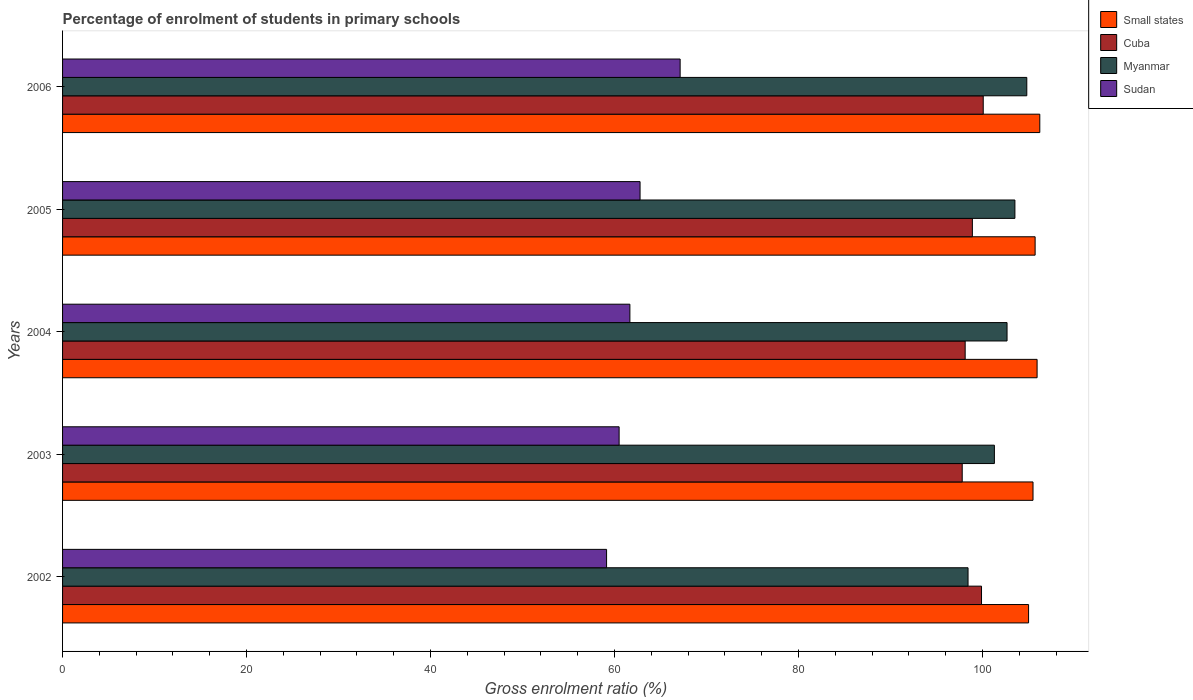How many different coloured bars are there?
Offer a terse response. 4. Are the number of bars per tick equal to the number of legend labels?
Your answer should be very brief. Yes. How many bars are there on the 5th tick from the top?
Give a very brief answer. 4. How many bars are there on the 5th tick from the bottom?
Your answer should be compact. 4. In how many cases, is the number of bars for a given year not equal to the number of legend labels?
Ensure brevity in your answer.  0. What is the percentage of students enrolled in primary schools in Sudan in 2004?
Your response must be concise. 61.67. Across all years, what is the maximum percentage of students enrolled in primary schools in Small states?
Provide a short and direct response. 106.23. Across all years, what is the minimum percentage of students enrolled in primary schools in Sudan?
Offer a terse response. 59.14. In which year was the percentage of students enrolled in primary schools in Cuba maximum?
Keep it short and to the point. 2006. In which year was the percentage of students enrolled in primary schools in Myanmar minimum?
Provide a short and direct response. 2002. What is the total percentage of students enrolled in primary schools in Small states in the graph?
Ensure brevity in your answer.  528.38. What is the difference between the percentage of students enrolled in primary schools in Myanmar in 2002 and that in 2006?
Your response must be concise. -6.39. What is the difference between the percentage of students enrolled in primary schools in Small states in 2005 and the percentage of students enrolled in primary schools in Cuba in 2002?
Ensure brevity in your answer.  5.83. What is the average percentage of students enrolled in primary schools in Sudan per year?
Ensure brevity in your answer.  62.24. In the year 2004, what is the difference between the percentage of students enrolled in primary schools in Myanmar and percentage of students enrolled in primary schools in Sudan?
Keep it short and to the point. 41. What is the ratio of the percentage of students enrolled in primary schools in Cuba in 2004 to that in 2005?
Your response must be concise. 0.99. What is the difference between the highest and the second highest percentage of students enrolled in primary schools in Small states?
Your answer should be very brief. 0.29. What is the difference between the highest and the lowest percentage of students enrolled in primary schools in Small states?
Offer a terse response. 1.22. Is the sum of the percentage of students enrolled in primary schools in Myanmar in 2002 and 2003 greater than the maximum percentage of students enrolled in primary schools in Small states across all years?
Provide a short and direct response. Yes. Is it the case that in every year, the sum of the percentage of students enrolled in primary schools in Sudan and percentage of students enrolled in primary schools in Cuba is greater than the sum of percentage of students enrolled in primary schools in Myanmar and percentage of students enrolled in primary schools in Small states?
Offer a very short reply. Yes. What does the 4th bar from the top in 2006 represents?
Give a very brief answer. Small states. What does the 4th bar from the bottom in 2004 represents?
Provide a short and direct response. Sudan. Is it the case that in every year, the sum of the percentage of students enrolled in primary schools in Sudan and percentage of students enrolled in primary schools in Cuba is greater than the percentage of students enrolled in primary schools in Small states?
Give a very brief answer. Yes. How many bars are there?
Your answer should be very brief. 20. Are all the bars in the graph horizontal?
Offer a very short reply. Yes. What is the difference between two consecutive major ticks on the X-axis?
Provide a succinct answer. 20. Does the graph contain grids?
Keep it short and to the point. No. What is the title of the graph?
Keep it short and to the point. Percentage of enrolment of students in primary schools. Does "Curacao" appear as one of the legend labels in the graph?
Your answer should be very brief. No. What is the label or title of the X-axis?
Your answer should be compact. Gross enrolment ratio (%). What is the label or title of the Y-axis?
Offer a very short reply. Years. What is the Gross enrolment ratio (%) in Small states in 2002?
Give a very brief answer. 105.01. What is the Gross enrolment ratio (%) of Cuba in 2002?
Ensure brevity in your answer.  99.89. What is the Gross enrolment ratio (%) in Myanmar in 2002?
Give a very brief answer. 98.43. What is the Gross enrolment ratio (%) in Sudan in 2002?
Provide a succinct answer. 59.14. What is the Gross enrolment ratio (%) of Small states in 2003?
Make the answer very short. 105.49. What is the Gross enrolment ratio (%) of Cuba in 2003?
Ensure brevity in your answer.  97.79. What is the Gross enrolment ratio (%) of Myanmar in 2003?
Give a very brief answer. 101.29. What is the Gross enrolment ratio (%) of Sudan in 2003?
Your answer should be very brief. 60.5. What is the Gross enrolment ratio (%) in Small states in 2004?
Make the answer very short. 105.93. What is the Gross enrolment ratio (%) of Cuba in 2004?
Your response must be concise. 98.12. What is the Gross enrolment ratio (%) in Myanmar in 2004?
Make the answer very short. 102.67. What is the Gross enrolment ratio (%) of Sudan in 2004?
Make the answer very short. 61.67. What is the Gross enrolment ratio (%) of Small states in 2005?
Your answer should be very brief. 105.72. What is the Gross enrolment ratio (%) of Cuba in 2005?
Your response must be concise. 98.9. What is the Gross enrolment ratio (%) of Myanmar in 2005?
Your answer should be very brief. 103.52. What is the Gross enrolment ratio (%) of Sudan in 2005?
Provide a short and direct response. 62.78. What is the Gross enrolment ratio (%) of Small states in 2006?
Offer a very short reply. 106.23. What is the Gross enrolment ratio (%) in Cuba in 2006?
Give a very brief answer. 100.08. What is the Gross enrolment ratio (%) of Myanmar in 2006?
Your answer should be very brief. 104.82. What is the Gross enrolment ratio (%) of Sudan in 2006?
Keep it short and to the point. 67.13. Across all years, what is the maximum Gross enrolment ratio (%) of Small states?
Your answer should be compact. 106.23. Across all years, what is the maximum Gross enrolment ratio (%) in Cuba?
Keep it short and to the point. 100.08. Across all years, what is the maximum Gross enrolment ratio (%) in Myanmar?
Your response must be concise. 104.82. Across all years, what is the maximum Gross enrolment ratio (%) in Sudan?
Keep it short and to the point. 67.13. Across all years, what is the minimum Gross enrolment ratio (%) in Small states?
Make the answer very short. 105.01. Across all years, what is the minimum Gross enrolment ratio (%) in Cuba?
Provide a short and direct response. 97.79. Across all years, what is the minimum Gross enrolment ratio (%) in Myanmar?
Ensure brevity in your answer.  98.43. Across all years, what is the minimum Gross enrolment ratio (%) of Sudan?
Make the answer very short. 59.14. What is the total Gross enrolment ratio (%) of Small states in the graph?
Offer a terse response. 528.38. What is the total Gross enrolment ratio (%) in Cuba in the graph?
Offer a terse response. 494.78. What is the total Gross enrolment ratio (%) in Myanmar in the graph?
Your answer should be compact. 510.72. What is the total Gross enrolment ratio (%) of Sudan in the graph?
Offer a terse response. 311.21. What is the difference between the Gross enrolment ratio (%) in Small states in 2002 and that in 2003?
Ensure brevity in your answer.  -0.48. What is the difference between the Gross enrolment ratio (%) of Cuba in 2002 and that in 2003?
Offer a terse response. 2.1. What is the difference between the Gross enrolment ratio (%) of Myanmar in 2002 and that in 2003?
Provide a succinct answer. -2.86. What is the difference between the Gross enrolment ratio (%) of Sudan in 2002 and that in 2003?
Offer a terse response. -1.36. What is the difference between the Gross enrolment ratio (%) in Small states in 2002 and that in 2004?
Provide a succinct answer. -0.93. What is the difference between the Gross enrolment ratio (%) in Cuba in 2002 and that in 2004?
Provide a succinct answer. 1.78. What is the difference between the Gross enrolment ratio (%) of Myanmar in 2002 and that in 2004?
Offer a very short reply. -4.24. What is the difference between the Gross enrolment ratio (%) in Sudan in 2002 and that in 2004?
Your answer should be compact. -2.53. What is the difference between the Gross enrolment ratio (%) of Small states in 2002 and that in 2005?
Your response must be concise. -0.71. What is the difference between the Gross enrolment ratio (%) in Cuba in 2002 and that in 2005?
Ensure brevity in your answer.  0.99. What is the difference between the Gross enrolment ratio (%) in Myanmar in 2002 and that in 2005?
Give a very brief answer. -5.09. What is the difference between the Gross enrolment ratio (%) of Sudan in 2002 and that in 2005?
Offer a terse response. -3.64. What is the difference between the Gross enrolment ratio (%) in Small states in 2002 and that in 2006?
Your answer should be very brief. -1.22. What is the difference between the Gross enrolment ratio (%) in Cuba in 2002 and that in 2006?
Offer a very short reply. -0.19. What is the difference between the Gross enrolment ratio (%) in Myanmar in 2002 and that in 2006?
Ensure brevity in your answer.  -6.39. What is the difference between the Gross enrolment ratio (%) in Sudan in 2002 and that in 2006?
Ensure brevity in your answer.  -8. What is the difference between the Gross enrolment ratio (%) in Small states in 2003 and that in 2004?
Your answer should be compact. -0.44. What is the difference between the Gross enrolment ratio (%) in Cuba in 2003 and that in 2004?
Your answer should be compact. -0.32. What is the difference between the Gross enrolment ratio (%) in Myanmar in 2003 and that in 2004?
Offer a very short reply. -1.38. What is the difference between the Gross enrolment ratio (%) in Sudan in 2003 and that in 2004?
Your response must be concise. -1.17. What is the difference between the Gross enrolment ratio (%) of Small states in 2003 and that in 2005?
Give a very brief answer. -0.23. What is the difference between the Gross enrolment ratio (%) in Cuba in 2003 and that in 2005?
Your answer should be very brief. -1.1. What is the difference between the Gross enrolment ratio (%) in Myanmar in 2003 and that in 2005?
Offer a very short reply. -2.23. What is the difference between the Gross enrolment ratio (%) in Sudan in 2003 and that in 2005?
Your response must be concise. -2.28. What is the difference between the Gross enrolment ratio (%) of Small states in 2003 and that in 2006?
Provide a short and direct response. -0.74. What is the difference between the Gross enrolment ratio (%) of Cuba in 2003 and that in 2006?
Your answer should be very brief. -2.29. What is the difference between the Gross enrolment ratio (%) of Myanmar in 2003 and that in 2006?
Your answer should be compact. -3.52. What is the difference between the Gross enrolment ratio (%) in Sudan in 2003 and that in 2006?
Provide a short and direct response. -6.63. What is the difference between the Gross enrolment ratio (%) in Small states in 2004 and that in 2005?
Your answer should be compact. 0.21. What is the difference between the Gross enrolment ratio (%) in Cuba in 2004 and that in 2005?
Offer a terse response. -0.78. What is the difference between the Gross enrolment ratio (%) in Myanmar in 2004 and that in 2005?
Offer a terse response. -0.86. What is the difference between the Gross enrolment ratio (%) of Sudan in 2004 and that in 2005?
Your answer should be very brief. -1.11. What is the difference between the Gross enrolment ratio (%) of Small states in 2004 and that in 2006?
Offer a very short reply. -0.29. What is the difference between the Gross enrolment ratio (%) of Cuba in 2004 and that in 2006?
Your answer should be very brief. -1.96. What is the difference between the Gross enrolment ratio (%) of Myanmar in 2004 and that in 2006?
Offer a terse response. -2.15. What is the difference between the Gross enrolment ratio (%) of Sudan in 2004 and that in 2006?
Your response must be concise. -5.46. What is the difference between the Gross enrolment ratio (%) of Small states in 2005 and that in 2006?
Your answer should be very brief. -0.51. What is the difference between the Gross enrolment ratio (%) in Cuba in 2005 and that in 2006?
Offer a terse response. -1.18. What is the difference between the Gross enrolment ratio (%) of Myanmar in 2005 and that in 2006?
Make the answer very short. -1.29. What is the difference between the Gross enrolment ratio (%) in Sudan in 2005 and that in 2006?
Keep it short and to the point. -4.36. What is the difference between the Gross enrolment ratio (%) of Small states in 2002 and the Gross enrolment ratio (%) of Cuba in 2003?
Offer a terse response. 7.21. What is the difference between the Gross enrolment ratio (%) of Small states in 2002 and the Gross enrolment ratio (%) of Myanmar in 2003?
Offer a very short reply. 3.72. What is the difference between the Gross enrolment ratio (%) of Small states in 2002 and the Gross enrolment ratio (%) of Sudan in 2003?
Keep it short and to the point. 44.51. What is the difference between the Gross enrolment ratio (%) in Cuba in 2002 and the Gross enrolment ratio (%) in Myanmar in 2003?
Provide a short and direct response. -1.4. What is the difference between the Gross enrolment ratio (%) in Cuba in 2002 and the Gross enrolment ratio (%) in Sudan in 2003?
Provide a short and direct response. 39.39. What is the difference between the Gross enrolment ratio (%) in Myanmar in 2002 and the Gross enrolment ratio (%) in Sudan in 2003?
Offer a terse response. 37.93. What is the difference between the Gross enrolment ratio (%) in Small states in 2002 and the Gross enrolment ratio (%) in Cuba in 2004?
Offer a very short reply. 6.89. What is the difference between the Gross enrolment ratio (%) in Small states in 2002 and the Gross enrolment ratio (%) in Myanmar in 2004?
Provide a short and direct response. 2.34. What is the difference between the Gross enrolment ratio (%) of Small states in 2002 and the Gross enrolment ratio (%) of Sudan in 2004?
Keep it short and to the point. 43.34. What is the difference between the Gross enrolment ratio (%) in Cuba in 2002 and the Gross enrolment ratio (%) in Myanmar in 2004?
Ensure brevity in your answer.  -2.77. What is the difference between the Gross enrolment ratio (%) of Cuba in 2002 and the Gross enrolment ratio (%) of Sudan in 2004?
Keep it short and to the point. 38.22. What is the difference between the Gross enrolment ratio (%) of Myanmar in 2002 and the Gross enrolment ratio (%) of Sudan in 2004?
Your answer should be very brief. 36.76. What is the difference between the Gross enrolment ratio (%) of Small states in 2002 and the Gross enrolment ratio (%) of Cuba in 2005?
Your answer should be compact. 6.11. What is the difference between the Gross enrolment ratio (%) in Small states in 2002 and the Gross enrolment ratio (%) in Myanmar in 2005?
Your response must be concise. 1.49. What is the difference between the Gross enrolment ratio (%) of Small states in 2002 and the Gross enrolment ratio (%) of Sudan in 2005?
Your answer should be compact. 42.23. What is the difference between the Gross enrolment ratio (%) in Cuba in 2002 and the Gross enrolment ratio (%) in Myanmar in 2005?
Provide a short and direct response. -3.63. What is the difference between the Gross enrolment ratio (%) in Cuba in 2002 and the Gross enrolment ratio (%) in Sudan in 2005?
Give a very brief answer. 37.12. What is the difference between the Gross enrolment ratio (%) in Myanmar in 2002 and the Gross enrolment ratio (%) in Sudan in 2005?
Make the answer very short. 35.65. What is the difference between the Gross enrolment ratio (%) of Small states in 2002 and the Gross enrolment ratio (%) of Cuba in 2006?
Your response must be concise. 4.93. What is the difference between the Gross enrolment ratio (%) in Small states in 2002 and the Gross enrolment ratio (%) in Myanmar in 2006?
Make the answer very short. 0.19. What is the difference between the Gross enrolment ratio (%) of Small states in 2002 and the Gross enrolment ratio (%) of Sudan in 2006?
Provide a succinct answer. 37.88. What is the difference between the Gross enrolment ratio (%) in Cuba in 2002 and the Gross enrolment ratio (%) in Myanmar in 2006?
Offer a terse response. -4.92. What is the difference between the Gross enrolment ratio (%) in Cuba in 2002 and the Gross enrolment ratio (%) in Sudan in 2006?
Offer a very short reply. 32.76. What is the difference between the Gross enrolment ratio (%) of Myanmar in 2002 and the Gross enrolment ratio (%) of Sudan in 2006?
Give a very brief answer. 31.3. What is the difference between the Gross enrolment ratio (%) in Small states in 2003 and the Gross enrolment ratio (%) in Cuba in 2004?
Ensure brevity in your answer.  7.37. What is the difference between the Gross enrolment ratio (%) of Small states in 2003 and the Gross enrolment ratio (%) of Myanmar in 2004?
Provide a succinct answer. 2.82. What is the difference between the Gross enrolment ratio (%) in Small states in 2003 and the Gross enrolment ratio (%) in Sudan in 2004?
Make the answer very short. 43.82. What is the difference between the Gross enrolment ratio (%) in Cuba in 2003 and the Gross enrolment ratio (%) in Myanmar in 2004?
Your answer should be very brief. -4.87. What is the difference between the Gross enrolment ratio (%) of Cuba in 2003 and the Gross enrolment ratio (%) of Sudan in 2004?
Your answer should be very brief. 36.12. What is the difference between the Gross enrolment ratio (%) of Myanmar in 2003 and the Gross enrolment ratio (%) of Sudan in 2004?
Your answer should be compact. 39.62. What is the difference between the Gross enrolment ratio (%) of Small states in 2003 and the Gross enrolment ratio (%) of Cuba in 2005?
Give a very brief answer. 6.59. What is the difference between the Gross enrolment ratio (%) in Small states in 2003 and the Gross enrolment ratio (%) in Myanmar in 2005?
Provide a short and direct response. 1.97. What is the difference between the Gross enrolment ratio (%) of Small states in 2003 and the Gross enrolment ratio (%) of Sudan in 2005?
Your answer should be very brief. 42.71. What is the difference between the Gross enrolment ratio (%) of Cuba in 2003 and the Gross enrolment ratio (%) of Myanmar in 2005?
Keep it short and to the point. -5.73. What is the difference between the Gross enrolment ratio (%) of Cuba in 2003 and the Gross enrolment ratio (%) of Sudan in 2005?
Offer a very short reply. 35.02. What is the difference between the Gross enrolment ratio (%) in Myanmar in 2003 and the Gross enrolment ratio (%) in Sudan in 2005?
Give a very brief answer. 38.52. What is the difference between the Gross enrolment ratio (%) of Small states in 2003 and the Gross enrolment ratio (%) of Cuba in 2006?
Ensure brevity in your answer.  5.41. What is the difference between the Gross enrolment ratio (%) in Small states in 2003 and the Gross enrolment ratio (%) in Myanmar in 2006?
Keep it short and to the point. 0.68. What is the difference between the Gross enrolment ratio (%) in Small states in 2003 and the Gross enrolment ratio (%) in Sudan in 2006?
Your answer should be very brief. 38.36. What is the difference between the Gross enrolment ratio (%) of Cuba in 2003 and the Gross enrolment ratio (%) of Myanmar in 2006?
Your answer should be very brief. -7.02. What is the difference between the Gross enrolment ratio (%) of Cuba in 2003 and the Gross enrolment ratio (%) of Sudan in 2006?
Ensure brevity in your answer.  30.66. What is the difference between the Gross enrolment ratio (%) of Myanmar in 2003 and the Gross enrolment ratio (%) of Sudan in 2006?
Make the answer very short. 34.16. What is the difference between the Gross enrolment ratio (%) in Small states in 2004 and the Gross enrolment ratio (%) in Cuba in 2005?
Provide a succinct answer. 7.04. What is the difference between the Gross enrolment ratio (%) of Small states in 2004 and the Gross enrolment ratio (%) of Myanmar in 2005?
Provide a succinct answer. 2.41. What is the difference between the Gross enrolment ratio (%) in Small states in 2004 and the Gross enrolment ratio (%) in Sudan in 2005?
Provide a succinct answer. 43.16. What is the difference between the Gross enrolment ratio (%) of Cuba in 2004 and the Gross enrolment ratio (%) of Myanmar in 2005?
Your answer should be compact. -5.41. What is the difference between the Gross enrolment ratio (%) in Cuba in 2004 and the Gross enrolment ratio (%) in Sudan in 2005?
Your response must be concise. 35.34. What is the difference between the Gross enrolment ratio (%) in Myanmar in 2004 and the Gross enrolment ratio (%) in Sudan in 2005?
Keep it short and to the point. 39.89. What is the difference between the Gross enrolment ratio (%) in Small states in 2004 and the Gross enrolment ratio (%) in Cuba in 2006?
Your response must be concise. 5.86. What is the difference between the Gross enrolment ratio (%) of Small states in 2004 and the Gross enrolment ratio (%) of Myanmar in 2006?
Keep it short and to the point. 1.12. What is the difference between the Gross enrolment ratio (%) in Small states in 2004 and the Gross enrolment ratio (%) in Sudan in 2006?
Keep it short and to the point. 38.8. What is the difference between the Gross enrolment ratio (%) in Cuba in 2004 and the Gross enrolment ratio (%) in Myanmar in 2006?
Offer a very short reply. -6.7. What is the difference between the Gross enrolment ratio (%) in Cuba in 2004 and the Gross enrolment ratio (%) in Sudan in 2006?
Make the answer very short. 30.98. What is the difference between the Gross enrolment ratio (%) in Myanmar in 2004 and the Gross enrolment ratio (%) in Sudan in 2006?
Make the answer very short. 35.54. What is the difference between the Gross enrolment ratio (%) of Small states in 2005 and the Gross enrolment ratio (%) of Cuba in 2006?
Offer a terse response. 5.64. What is the difference between the Gross enrolment ratio (%) in Small states in 2005 and the Gross enrolment ratio (%) in Myanmar in 2006?
Your answer should be compact. 0.9. What is the difference between the Gross enrolment ratio (%) in Small states in 2005 and the Gross enrolment ratio (%) in Sudan in 2006?
Offer a terse response. 38.59. What is the difference between the Gross enrolment ratio (%) in Cuba in 2005 and the Gross enrolment ratio (%) in Myanmar in 2006?
Give a very brief answer. -5.92. What is the difference between the Gross enrolment ratio (%) in Cuba in 2005 and the Gross enrolment ratio (%) in Sudan in 2006?
Ensure brevity in your answer.  31.77. What is the difference between the Gross enrolment ratio (%) in Myanmar in 2005 and the Gross enrolment ratio (%) in Sudan in 2006?
Offer a very short reply. 36.39. What is the average Gross enrolment ratio (%) in Small states per year?
Your response must be concise. 105.68. What is the average Gross enrolment ratio (%) in Cuba per year?
Your response must be concise. 98.96. What is the average Gross enrolment ratio (%) in Myanmar per year?
Give a very brief answer. 102.14. What is the average Gross enrolment ratio (%) of Sudan per year?
Make the answer very short. 62.24. In the year 2002, what is the difference between the Gross enrolment ratio (%) of Small states and Gross enrolment ratio (%) of Cuba?
Make the answer very short. 5.12. In the year 2002, what is the difference between the Gross enrolment ratio (%) in Small states and Gross enrolment ratio (%) in Myanmar?
Your answer should be very brief. 6.58. In the year 2002, what is the difference between the Gross enrolment ratio (%) in Small states and Gross enrolment ratio (%) in Sudan?
Keep it short and to the point. 45.87. In the year 2002, what is the difference between the Gross enrolment ratio (%) of Cuba and Gross enrolment ratio (%) of Myanmar?
Ensure brevity in your answer.  1.46. In the year 2002, what is the difference between the Gross enrolment ratio (%) of Cuba and Gross enrolment ratio (%) of Sudan?
Your response must be concise. 40.76. In the year 2002, what is the difference between the Gross enrolment ratio (%) in Myanmar and Gross enrolment ratio (%) in Sudan?
Offer a very short reply. 39.29. In the year 2003, what is the difference between the Gross enrolment ratio (%) of Small states and Gross enrolment ratio (%) of Cuba?
Your answer should be very brief. 7.7. In the year 2003, what is the difference between the Gross enrolment ratio (%) of Small states and Gross enrolment ratio (%) of Myanmar?
Provide a short and direct response. 4.2. In the year 2003, what is the difference between the Gross enrolment ratio (%) of Small states and Gross enrolment ratio (%) of Sudan?
Provide a succinct answer. 44.99. In the year 2003, what is the difference between the Gross enrolment ratio (%) in Cuba and Gross enrolment ratio (%) in Myanmar?
Make the answer very short. -3.5. In the year 2003, what is the difference between the Gross enrolment ratio (%) of Cuba and Gross enrolment ratio (%) of Sudan?
Give a very brief answer. 37.29. In the year 2003, what is the difference between the Gross enrolment ratio (%) of Myanmar and Gross enrolment ratio (%) of Sudan?
Provide a succinct answer. 40.79. In the year 2004, what is the difference between the Gross enrolment ratio (%) in Small states and Gross enrolment ratio (%) in Cuba?
Ensure brevity in your answer.  7.82. In the year 2004, what is the difference between the Gross enrolment ratio (%) in Small states and Gross enrolment ratio (%) in Myanmar?
Provide a succinct answer. 3.27. In the year 2004, what is the difference between the Gross enrolment ratio (%) in Small states and Gross enrolment ratio (%) in Sudan?
Offer a terse response. 44.27. In the year 2004, what is the difference between the Gross enrolment ratio (%) in Cuba and Gross enrolment ratio (%) in Myanmar?
Your response must be concise. -4.55. In the year 2004, what is the difference between the Gross enrolment ratio (%) of Cuba and Gross enrolment ratio (%) of Sudan?
Provide a succinct answer. 36.45. In the year 2004, what is the difference between the Gross enrolment ratio (%) in Myanmar and Gross enrolment ratio (%) in Sudan?
Your response must be concise. 41. In the year 2005, what is the difference between the Gross enrolment ratio (%) of Small states and Gross enrolment ratio (%) of Cuba?
Your answer should be compact. 6.82. In the year 2005, what is the difference between the Gross enrolment ratio (%) of Small states and Gross enrolment ratio (%) of Myanmar?
Your answer should be compact. 2.2. In the year 2005, what is the difference between the Gross enrolment ratio (%) in Small states and Gross enrolment ratio (%) in Sudan?
Keep it short and to the point. 42.94. In the year 2005, what is the difference between the Gross enrolment ratio (%) in Cuba and Gross enrolment ratio (%) in Myanmar?
Your response must be concise. -4.62. In the year 2005, what is the difference between the Gross enrolment ratio (%) of Cuba and Gross enrolment ratio (%) of Sudan?
Keep it short and to the point. 36.12. In the year 2005, what is the difference between the Gross enrolment ratio (%) of Myanmar and Gross enrolment ratio (%) of Sudan?
Keep it short and to the point. 40.75. In the year 2006, what is the difference between the Gross enrolment ratio (%) of Small states and Gross enrolment ratio (%) of Cuba?
Offer a terse response. 6.15. In the year 2006, what is the difference between the Gross enrolment ratio (%) in Small states and Gross enrolment ratio (%) in Myanmar?
Your answer should be very brief. 1.41. In the year 2006, what is the difference between the Gross enrolment ratio (%) in Small states and Gross enrolment ratio (%) in Sudan?
Provide a succinct answer. 39.1. In the year 2006, what is the difference between the Gross enrolment ratio (%) of Cuba and Gross enrolment ratio (%) of Myanmar?
Give a very brief answer. -4.74. In the year 2006, what is the difference between the Gross enrolment ratio (%) of Cuba and Gross enrolment ratio (%) of Sudan?
Your answer should be very brief. 32.95. In the year 2006, what is the difference between the Gross enrolment ratio (%) in Myanmar and Gross enrolment ratio (%) in Sudan?
Offer a very short reply. 37.68. What is the ratio of the Gross enrolment ratio (%) of Cuba in 2002 to that in 2003?
Ensure brevity in your answer.  1.02. What is the ratio of the Gross enrolment ratio (%) in Myanmar in 2002 to that in 2003?
Your response must be concise. 0.97. What is the ratio of the Gross enrolment ratio (%) of Sudan in 2002 to that in 2003?
Ensure brevity in your answer.  0.98. What is the ratio of the Gross enrolment ratio (%) in Small states in 2002 to that in 2004?
Offer a very short reply. 0.99. What is the ratio of the Gross enrolment ratio (%) of Cuba in 2002 to that in 2004?
Offer a terse response. 1.02. What is the ratio of the Gross enrolment ratio (%) in Myanmar in 2002 to that in 2004?
Make the answer very short. 0.96. What is the ratio of the Gross enrolment ratio (%) of Sudan in 2002 to that in 2004?
Provide a short and direct response. 0.96. What is the ratio of the Gross enrolment ratio (%) of Small states in 2002 to that in 2005?
Keep it short and to the point. 0.99. What is the ratio of the Gross enrolment ratio (%) of Cuba in 2002 to that in 2005?
Your response must be concise. 1.01. What is the ratio of the Gross enrolment ratio (%) of Myanmar in 2002 to that in 2005?
Provide a succinct answer. 0.95. What is the ratio of the Gross enrolment ratio (%) of Sudan in 2002 to that in 2005?
Offer a terse response. 0.94. What is the ratio of the Gross enrolment ratio (%) in Cuba in 2002 to that in 2006?
Your answer should be very brief. 1. What is the ratio of the Gross enrolment ratio (%) of Myanmar in 2002 to that in 2006?
Provide a short and direct response. 0.94. What is the ratio of the Gross enrolment ratio (%) in Sudan in 2002 to that in 2006?
Your answer should be very brief. 0.88. What is the ratio of the Gross enrolment ratio (%) in Myanmar in 2003 to that in 2004?
Ensure brevity in your answer.  0.99. What is the ratio of the Gross enrolment ratio (%) of Small states in 2003 to that in 2005?
Offer a very short reply. 1. What is the ratio of the Gross enrolment ratio (%) of Myanmar in 2003 to that in 2005?
Provide a short and direct response. 0.98. What is the ratio of the Gross enrolment ratio (%) in Sudan in 2003 to that in 2005?
Give a very brief answer. 0.96. What is the ratio of the Gross enrolment ratio (%) of Small states in 2003 to that in 2006?
Your answer should be very brief. 0.99. What is the ratio of the Gross enrolment ratio (%) of Cuba in 2003 to that in 2006?
Provide a short and direct response. 0.98. What is the ratio of the Gross enrolment ratio (%) in Myanmar in 2003 to that in 2006?
Give a very brief answer. 0.97. What is the ratio of the Gross enrolment ratio (%) of Sudan in 2003 to that in 2006?
Give a very brief answer. 0.9. What is the ratio of the Gross enrolment ratio (%) in Small states in 2004 to that in 2005?
Your response must be concise. 1. What is the ratio of the Gross enrolment ratio (%) in Cuba in 2004 to that in 2005?
Make the answer very short. 0.99. What is the ratio of the Gross enrolment ratio (%) in Myanmar in 2004 to that in 2005?
Your response must be concise. 0.99. What is the ratio of the Gross enrolment ratio (%) in Sudan in 2004 to that in 2005?
Keep it short and to the point. 0.98. What is the ratio of the Gross enrolment ratio (%) in Small states in 2004 to that in 2006?
Your answer should be compact. 1. What is the ratio of the Gross enrolment ratio (%) of Cuba in 2004 to that in 2006?
Keep it short and to the point. 0.98. What is the ratio of the Gross enrolment ratio (%) in Myanmar in 2004 to that in 2006?
Keep it short and to the point. 0.98. What is the ratio of the Gross enrolment ratio (%) in Sudan in 2004 to that in 2006?
Your answer should be compact. 0.92. What is the ratio of the Gross enrolment ratio (%) of Small states in 2005 to that in 2006?
Your answer should be very brief. 1. What is the ratio of the Gross enrolment ratio (%) of Cuba in 2005 to that in 2006?
Keep it short and to the point. 0.99. What is the ratio of the Gross enrolment ratio (%) in Sudan in 2005 to that in 2006?
Provide a short and direct response. 0.94. What is the difference between the highest and the second highest Gross enrolment ratio (%) in Small states?
Ensure brevity in your answer.  0.29. What is the difference between the highest and the second highest Gross enrolment ratio (%) of Cuba?
Your answer should be very brief. 0.19. What is the difference between the highest and the second highest Gross enrolment ratio (%) in Myanmar?
Give a very brief answer. 1.29. What is the difference between the highest and the second highest Gross enrolment ratio (%) of Sudan?
Make the answer very short. 4.36. What is the difference between the highest and the lowest Gross enrolment ratio (%) in Small states?
Keep it short and to the point. 1.22. What is the difference between the highest and the lowest Gross enrolment ratio (%) in Cuba?
Keep it short and to the point. 2.29. What is the difference between the highest and the lowest Gross enrolment ratio (%) in Myanmar?
Ensure brevity in your answer.  6.39. What is the difference between the highest and the lowest Gross enrolment ratio (%) of Sudan?
Your answer should be very brief. 8. 